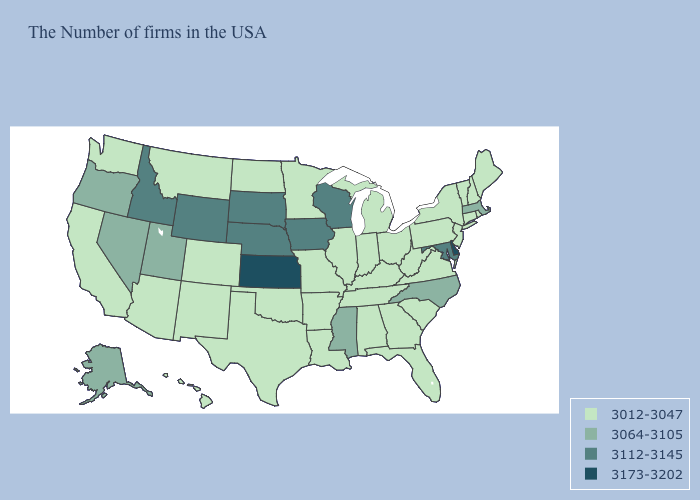What is the value of Wisconsin?
Write a very short answer. 3112-3145. Does Kansas have the highest value in the MidWest?
Keep it brief. Yes. Does Nevada have a higher value than Idaho?
Concise answer only. No. Which states hav the highest value in the South?
Short answer required. Delaware. Is the legend a continuous bar?
Keep it brief. No. What is the value of Kansas?
Keep it brief. 3173-3202. What is the lowest value in the USA?
Short answer required. 3012-3047. Which states have the lowest value in the USA?
Answer briefly. Maine, Rhode Island, New Hampshire, Vermont, Connecticut, New York, New Jersey, Pennsylvania, Virginia, South Carolina, West Virginia, Ohio, Florida, Georgia, Michigan, Kentucky, Indiana, Alabama, Tennessee, Illinois, Louisiana, Missouri, Arkansas, Minnesota, Oklahoma, Texas, North Dakota, Colorado, New Mexico, Montana, Arizona, California, Washington, Hawaii. Is the legend a continuous bar?
Answer briefly. No. Name the states that have a value in the range 3012-3047?
Give a very brief answer. Maine, Rhode Island, New Hampshire, Vermont, Connecticut, New York, New Jersey, Pennsylvania, Virginia, South Carolina, West Virginia, Ohio, Florida, Georgia, Michigan, Kentucky, Indiana, Alabama, Tennessee, Illinois, Louisiana, Missouri, Arkansas, Minnesota, Oklahoma, Texas, North Dakota, Colorado, New Mexico, Montana, Arizona, California, Washington, Hawaii. What is the lowest value in the Northeast?
Be succinct. 3012-3047. Does Montana have the same value as California?
Quick response, please. Yes. What is the highest value in the USA?
Write a very short answer. 3173-3202. What is the value of Nebraska?
Quick response, please. 3112-3145. 